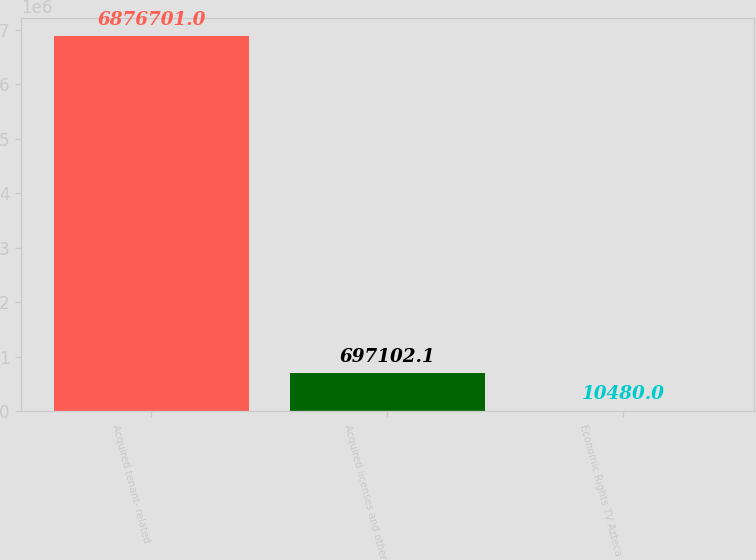<chart> <loc_0><loc_0><loc_500><loc_500><bar_chart><fcel>Acquired tenant- related<fcel>Acquired licenses and other<fcel>Economic Rights TV Azteca<nl><fcel>6.8767e+06<fcel>697102<fcel>10480<nl></chart> 